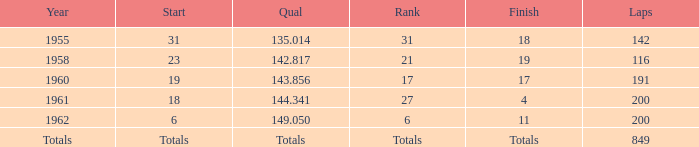Give me the full table as a dictionary. {'header': ['Year', 'Start', 'Qual', 'Rank', 'Finish', 'Laps'], 'rows': [['1955', '31', '135.014', '31', '18', '142'], ['1958', '23', '142.817', '21', '19', '116'], ['1960', '19', '143.856', '17', '17', '191'], ['1961', '18', '144.341', '27', '4', '200'], ['1962', '6', '149.050', '6', '11', '200'], ['Totals', 'Totals', 'Totals', 'Totals', 'Totals', '849']]} What is the year featuring 116 laps? 1958.0. 